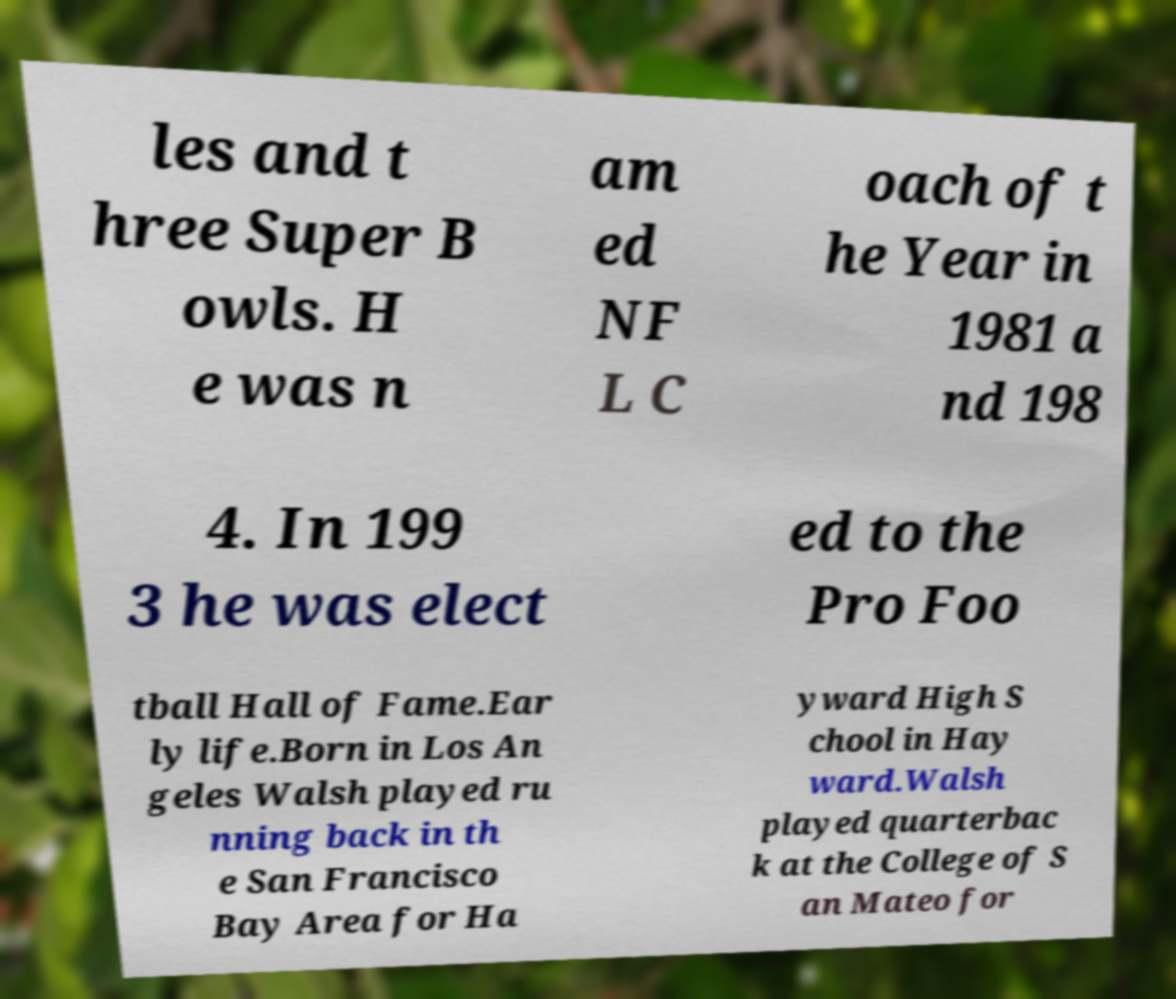I need the written content from this picture converted into text. Can you do that? les and t hree Super B owls. H e was n am ed NF L C oach of t he Year in 1981 a nd 198 4. In 199 3 he was elect ed to the Pro Foo tball Hall of Fame.Ear ly life.Born in Los An geles Walsh played ru nning back in th e San Francisco Bay Area for Ha yward High S chool in Hay ward.Walsh played quarterbac k at the College of S an Mateo for 